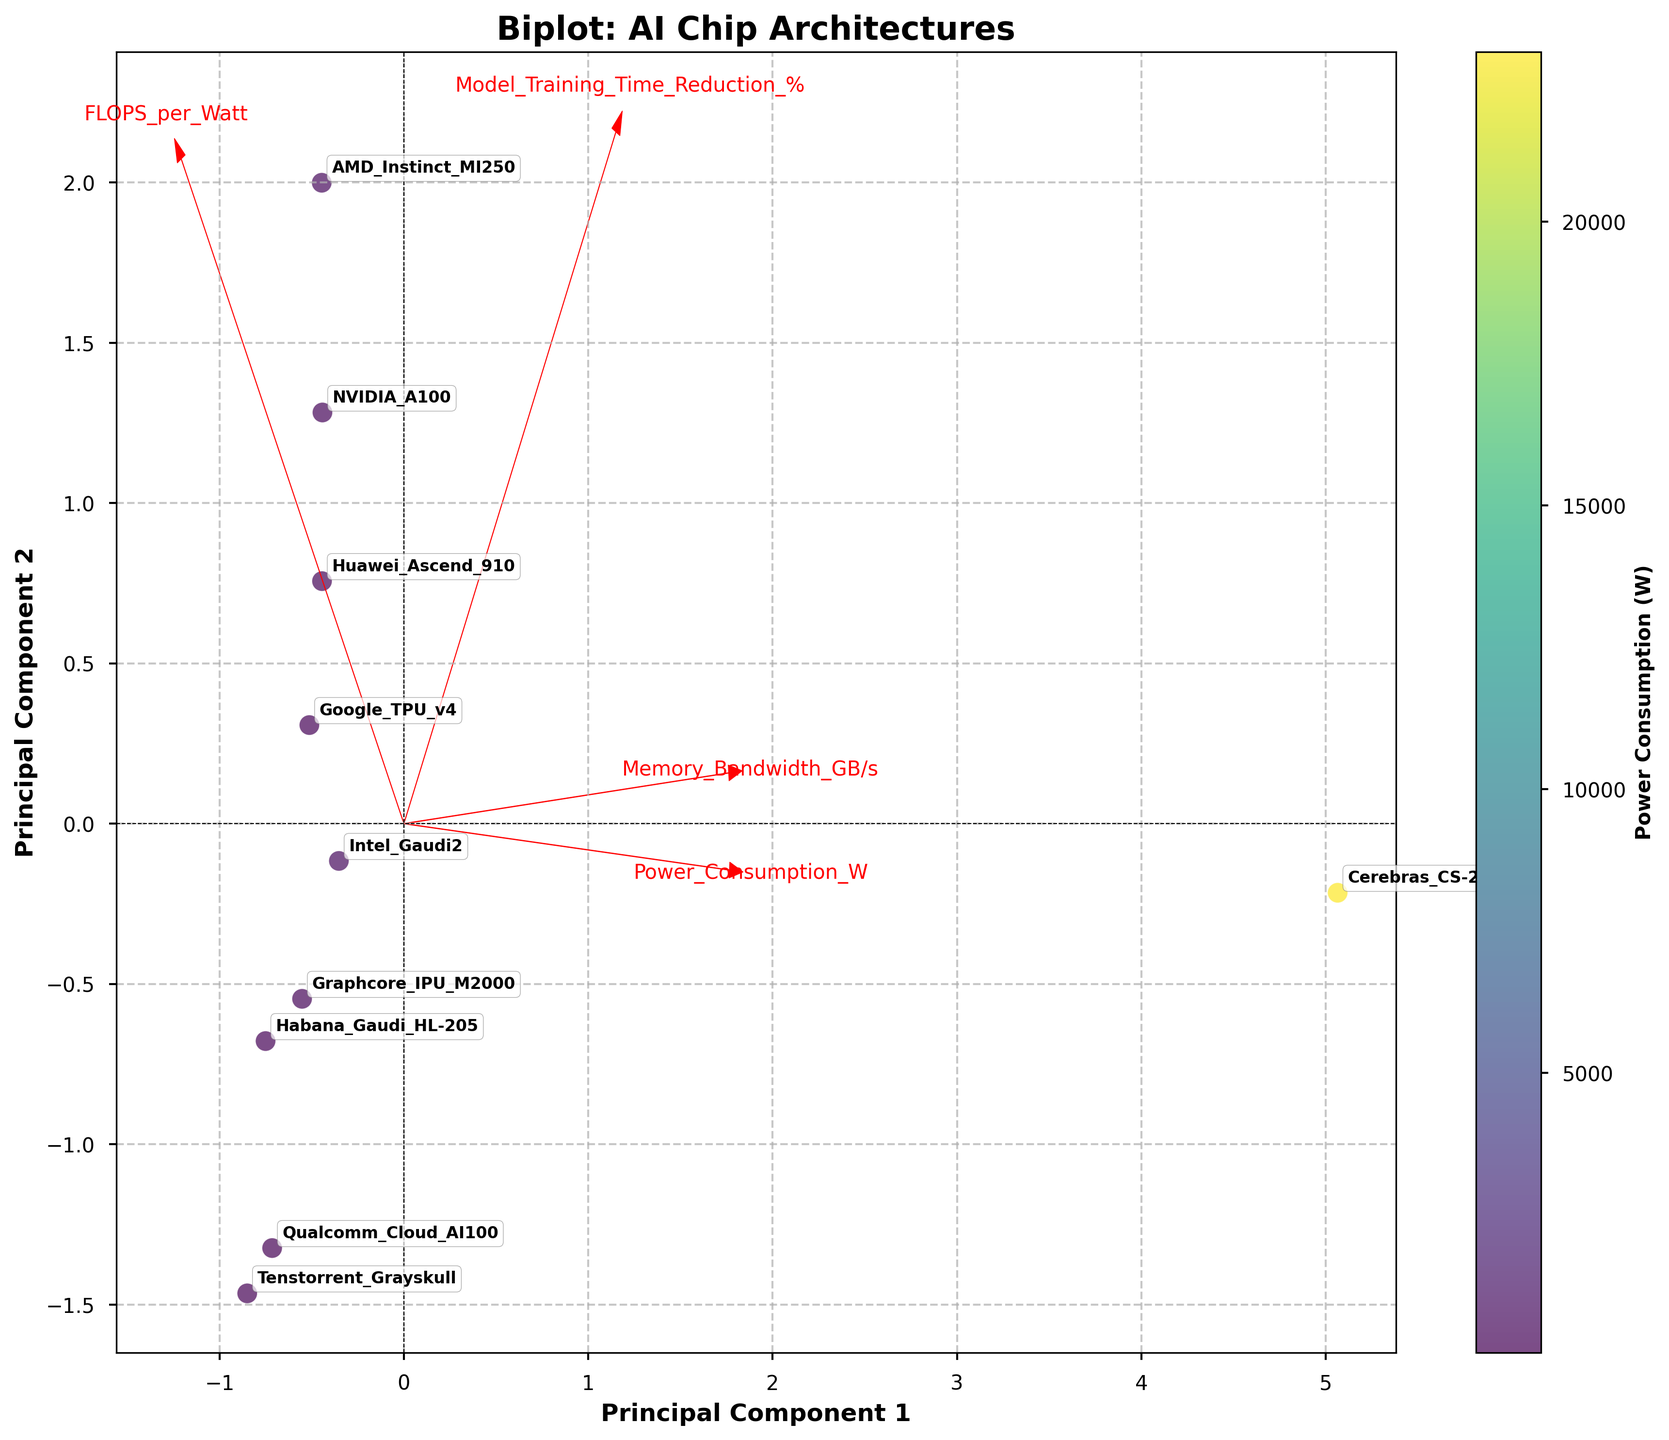What is the title of the biplot? The title of the biplot is usually found at the top of the figure. In this case, the title is visually presented in bold letters.
Answer: Biplot: AI Chip Architectures How many chip architectures are displayed in the plot? To determine the number of chip architectures, count the number of distinct labels annotated around the data points. Each label corresponds to a distinct chip architecture.
Answer: 10 Which chip architecture has the highest power consumption? The power consumption variable can be inferred from both the color gradient of the data points and their labels. Look for the chip architecture with the darkest color (indicating the highest power consumption).
Answer: Cerebras CS-2 What does the color of each data point represent? The color of each data point is indicated by the colorbar on the side of the plot, which shows a gradient scale associated with power consumption.
Answer: Power Consumption (W) Which chip architecture has the highest FLOPS per Watt? FLOPS per Watt is represented along with other variables by the position of data points on the plot. Look for the chip closest to the highest value on the respective axis.
Answer: AMD Instinct MI250 Which chip architectures have a power consumption of less than 100 W? Chip architectures with a power consumption of less than 100 W can be identified by looking for lighter colors on the data points and checking the labels corresponding to those points.
Answer: Qualcomm Cloud AI100 and Tenstorrent Grayskull How does the Nvidia A100 compare with the Google TPU v4 in terms of PC1 and PC2 scores? Look at the positions of Nvidia A100 and Google TPU v4 on the plot and compare their coordinates along the Principal Component 1 (x-axis) and Principal Component 2 (y-axis).
Answer: Nvidia A100 is higher on PC1 and lower on PC2 compared to Google TPU v4 What is the relationship between Memory Bandwidth and Power Consumption among the architectures? The variable vectors on the biplot (arrows) indicate the relationship. If the arrows for Memory Bandwidth and Power Consumption point in similar or opposite directions, that shows a relationship.
Answer: There is no direct clear relationship shown Which two chip architectures are closest to each other in the PC space? To find the closest chip architectures in the PC space, identify the two points that are nearest to each other on the plot.
Answer: Qualcomm Cloud AI100 and Tenstorrent Grayskull Which variable has the longest arrow in the plot? The length of the arrow can be measured from its starting point (origin) to its endpoint. The longest arrow is the one that extends the furthest.
Answer: Memory Bandwidth 